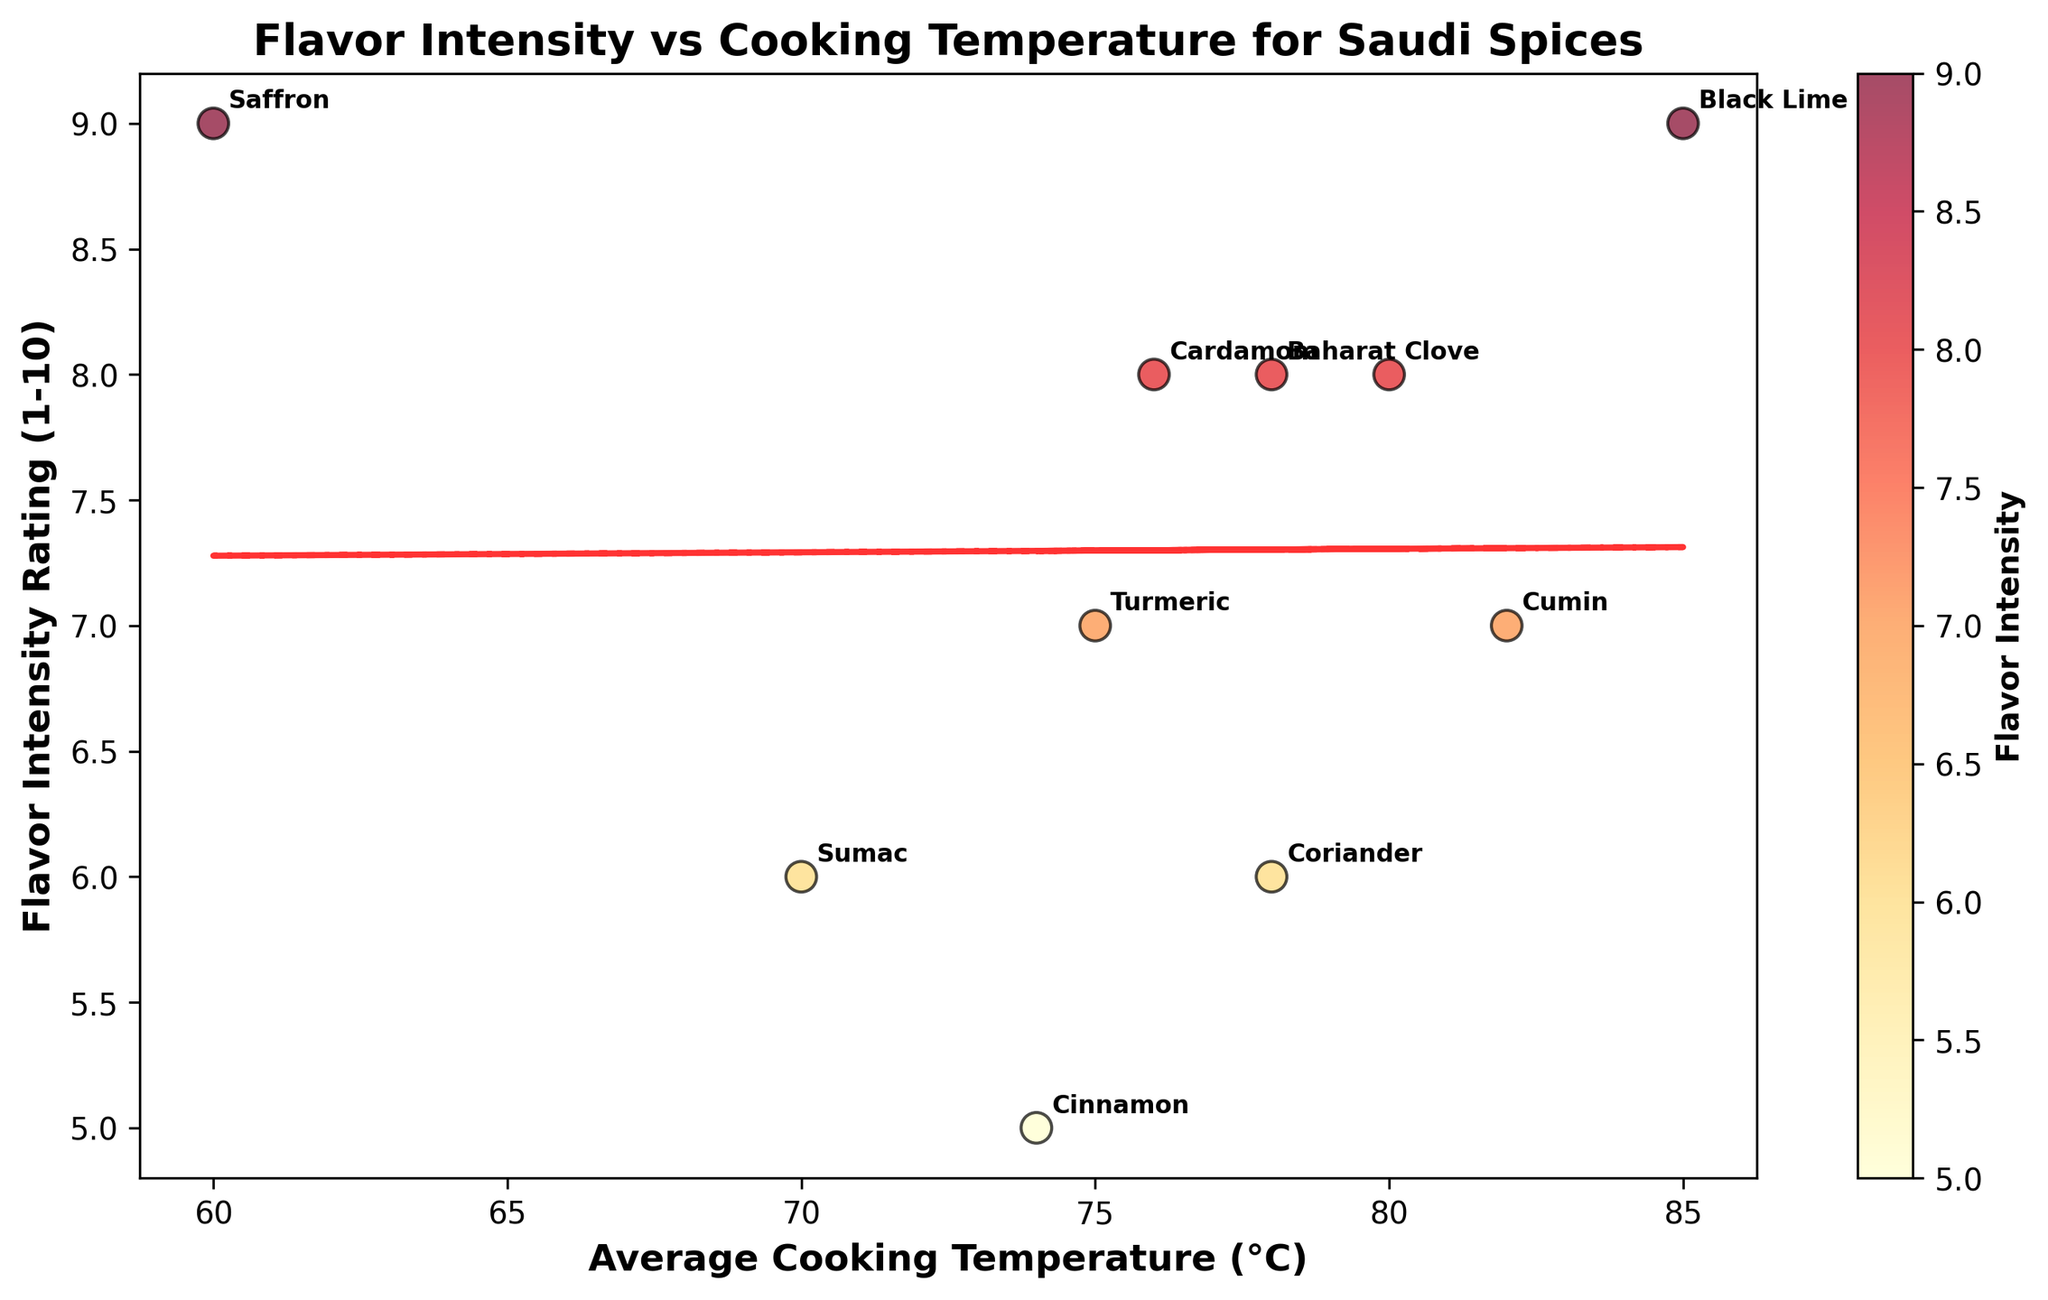What's the title of the figure? The title is typically located at the top of the figure and summarizes what the plot depicts.
Answer: Flavor Intensity vs Cooking Temperature for Saudi Spices How many spices are plotted in the scatter plot? Count the number of data points or labels on the scatter plot. There are labels for each data point which represent a spice.
Answer: 10 What is the range of Flavor Intensity Ratings on the plot? Check the y-axis (Flavor Intensity Rating) to find the minimum and maximum values.
Answer: 5 to 9 Which spice has the highest Flavor Intensity Rating? Locate the highest point on the y-axis (Flavor Intensity Rating) and check the label of that data point.
Answer: Black Lime or Saffron What is the average cooking temperature of Clove? Find the data point labeled 'Clove' and note its corresponding x-value (Average Cooking Temperature).
Answer: 80°C Which spice is cooked at the lowest average temperature? Locate the data point with the smallest x-value (Average Cooking Temperature) and check its label.
Answer: Saffron Do most spices cluster around a specific average cooking temperature? Look for regions where data points are densely packed on the x-axis.
Answer: Yes, around 75-80°C Is there a general trend between cooking temperature and flavor intensity? Observe the trend line in the scatter plot to determine the overall direction (positive/negative slope).
Answer: Positive trend Which spice has the lowest flavor intensity rating, and what is its average cooking temperature? Find the lowest point on the y-axis (Flavor Intensity Rating) and check its label and corresponding x-value.
Answer: Cinnamon, 74°C Are there more spices with an intensity rating above 7 than below? Count the number of points above and below the value of 7 on the y-axis (Flavor Intensity Rating).
Answer: Yes (6 above, 4 below) 